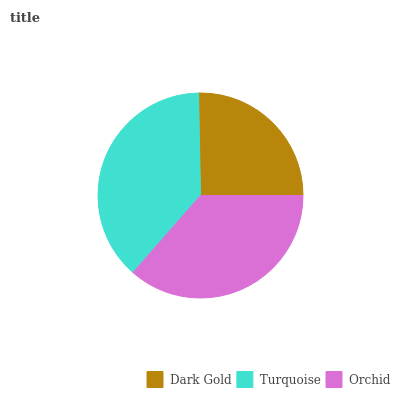Is Dark Gold the minimum?
Answer yes or no. Yes. Is Turquoise the maximum?
Answer yes or no. Yes. Is Orchid the minimum?
Answer yes or no. No. Is Orchid the maximum?
Answer yes or no. No. Is Turquoise greater than Orchid?
Answer yes or no. Yes. Is Orchid less than Turquoise?
Answer yes or no. Yes. Is Orchid greater than Turquoise?
Answer yes or no. No. Is Turquoise less than Orchid?
Answer yes or no. No. Is Orchid the high median?
Answer yes or no. Yes. Is Orchid the low median?
Answer yes or no. Yes. Is Turquoise the high median?
Answer yes or no. No. Is Dark Gold the low median?
Answer yes or no. No. 